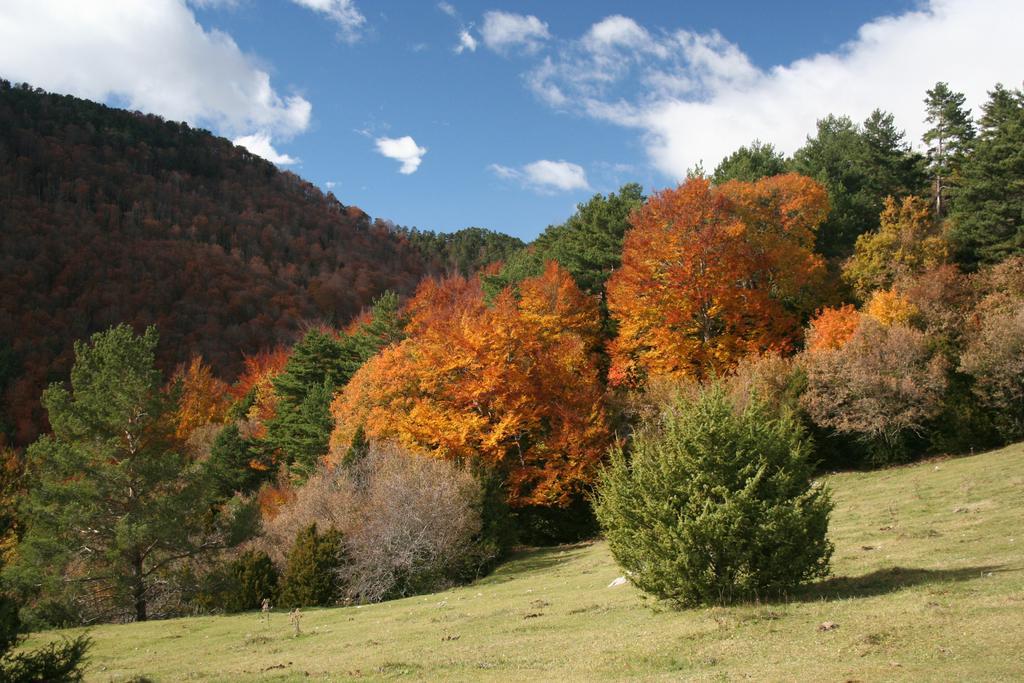Describe this image in one or two sentences. In this picture we can see many trees. On the bottom we can see grass. Here it's a plant. On the left we can see a mountain. On the top we can see sky and clouds. 